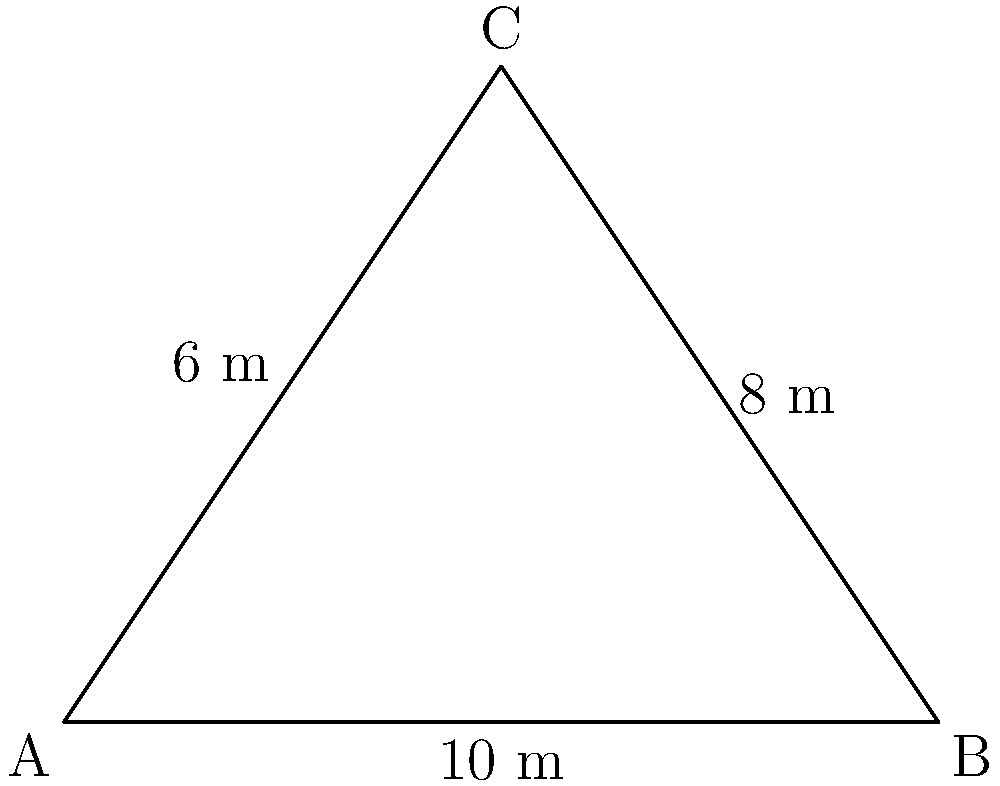Our ancestors have designated a sacred triangular site for an important ceremony. The elders have tasked you with enclosing this area with a single continuous rope. Given that the sides of the triangular site measure 10 m, 8 m, and 6 m, how much rope (in meters) will you need to completely enclose the sacred space? To find the length of rope needed, we must calculate the perimeter of the triangle. The perimeter is the sum of all sides of the triangle.

Given:
- Side 1 = 10 m
- Side 2 = 8 m
- Side 3 = 6 m

Step 1: Add the lengths of all sides
Perimeter = Side 1 + Side 2 + Side 3
Perimeter = 10 m + 8 m + 6 m

Step 2: Perform the addition
Perimeter = 24 m

Therefore, you will need 24 meters of rope to completely enclose the sacred triangular site.
Answer: 24 m 